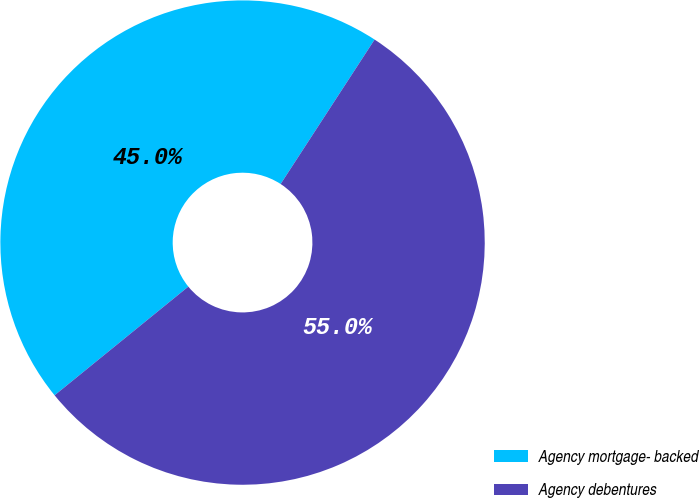<chart> <loc_0><loc_0><loc_500><loc_500><pie_chart><fcel>Agency mortgage- backed<fcel>Agency debentures<nl><fcel>45.04%<fcel>54.96%<nl></chart> 